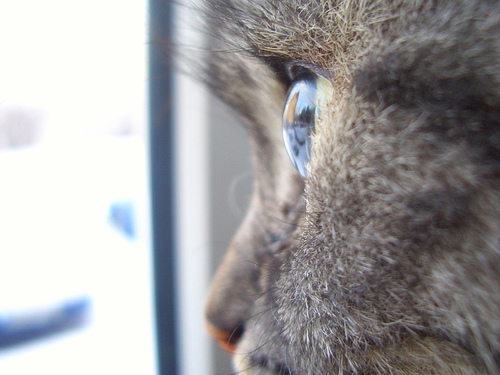<image>What color is the cat's right eye? I am not sure what color the cat's right eye is. It can be blue, gold, brown, green, or black. What color is the cat's right eye? I don't know the color of the cat's right eye. It is possible that it is blue, gold, brown, green, or black. 